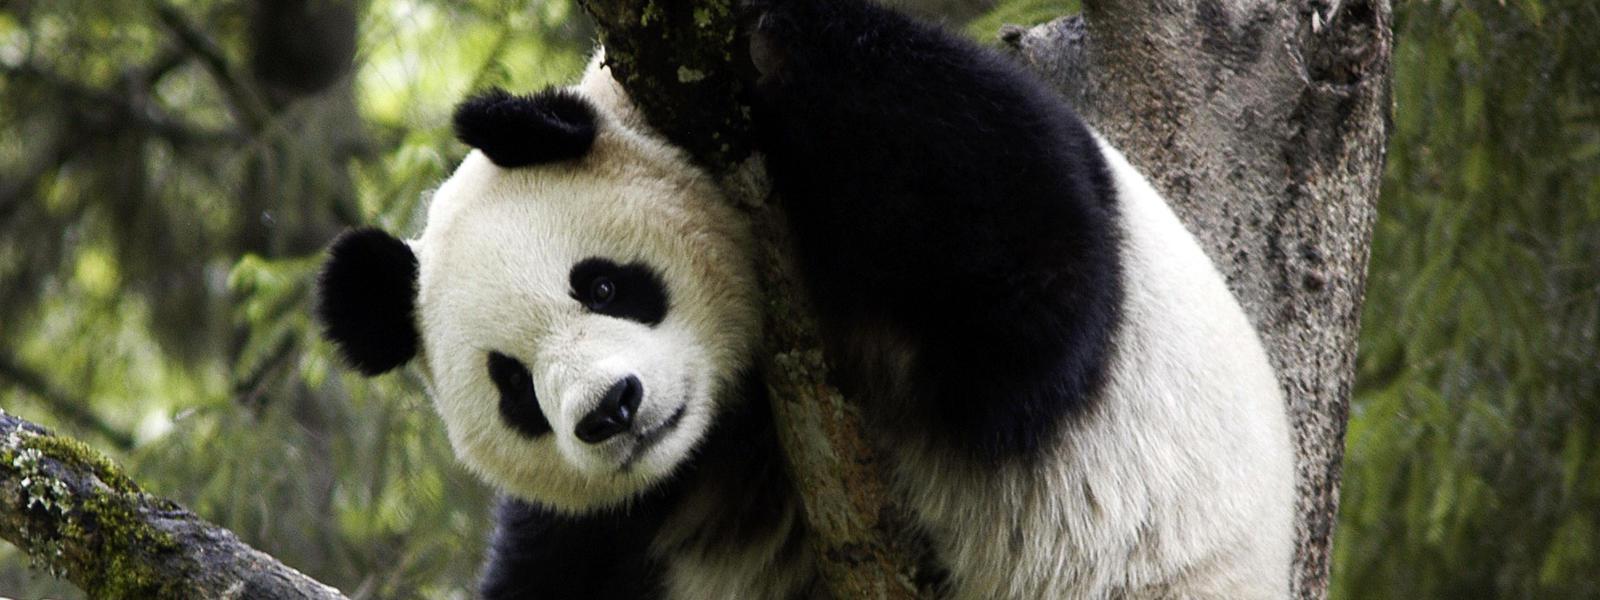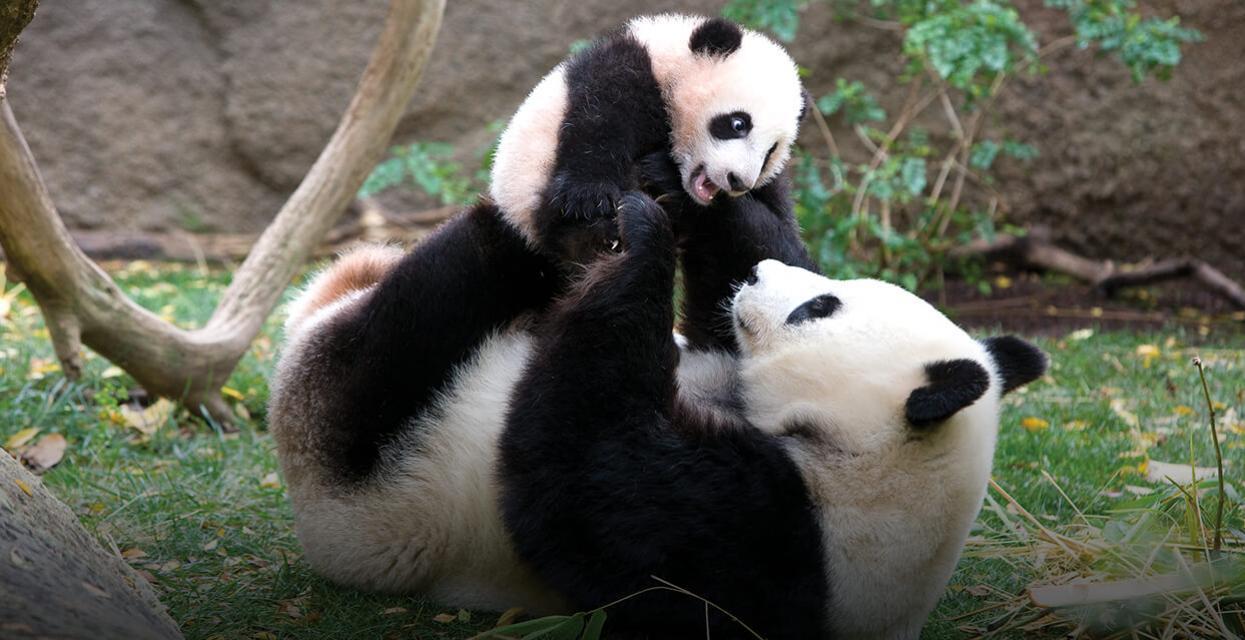The first image is the image on the left, the second image is the image on the right. Examine the images to the left and right. Is the description "The panda on the left is in a tree." accurate? Answer yes or no. Yes. The first image is the image on the left, the second image is the image on the right. Evaluate the accuracy of this statement regarding the images: "An image includes a panda at least partly lying on its back on green ground.". Is it true? Answer yes or no. Yes. 